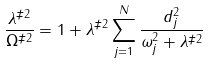Convert formula to latex. <formula><loc_0><loc_0><loc_500><loc_500>\frac { \lambda ^ { \ddag 2 } } { \Omega ^ { \ddag 2 } } = 1 + \lambda ^ { \ddag 2 } \sum _ { j = 1 } ^ { N } \frac { d _ { j } ^ { 2 } } { \omega _ { j } ^ { 2 } + \lambda ^ { \ddag 2 } }</formula> 